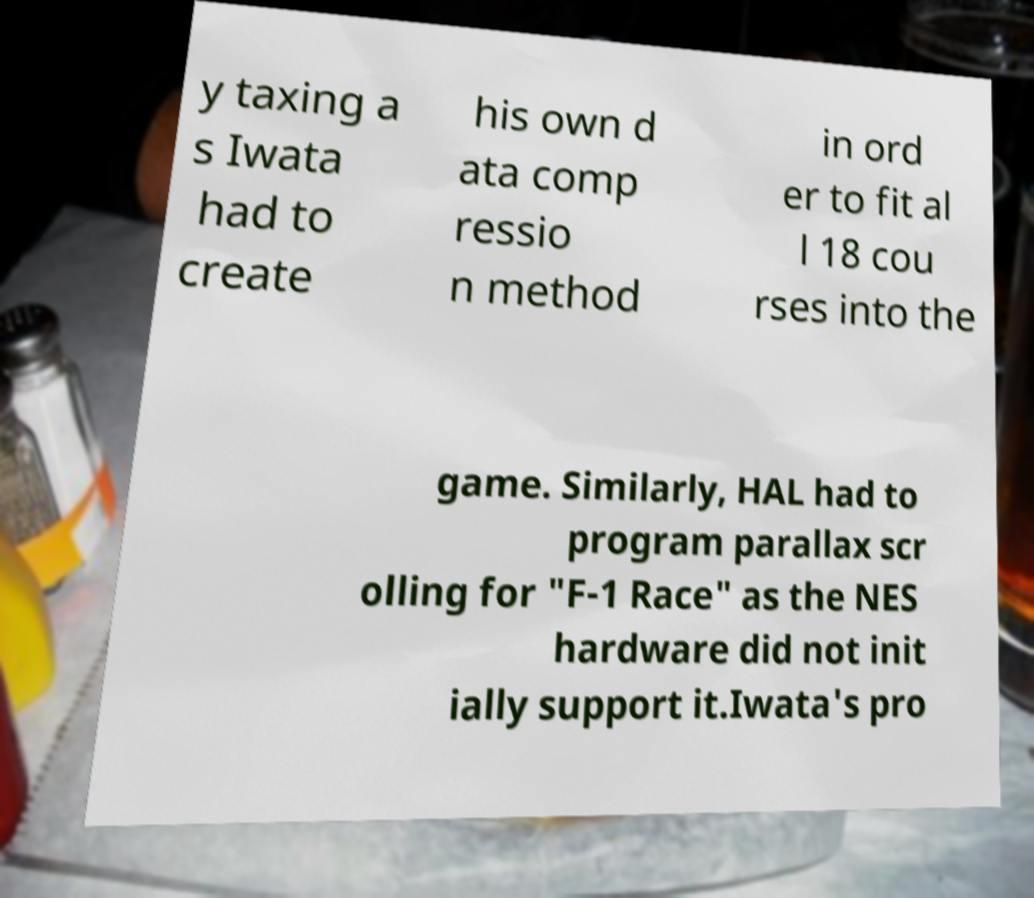Can you accurately transcribe the text from the provided image for me? y taxing a s Iwata had to create his own d ata comp ressio n method in ord er to fit al l 18 cou rses into the game. Similarly, HAL had to program parallax scr olling for "F-1 Race" as the NES hardware did not init ially support it.Iwata's pro 